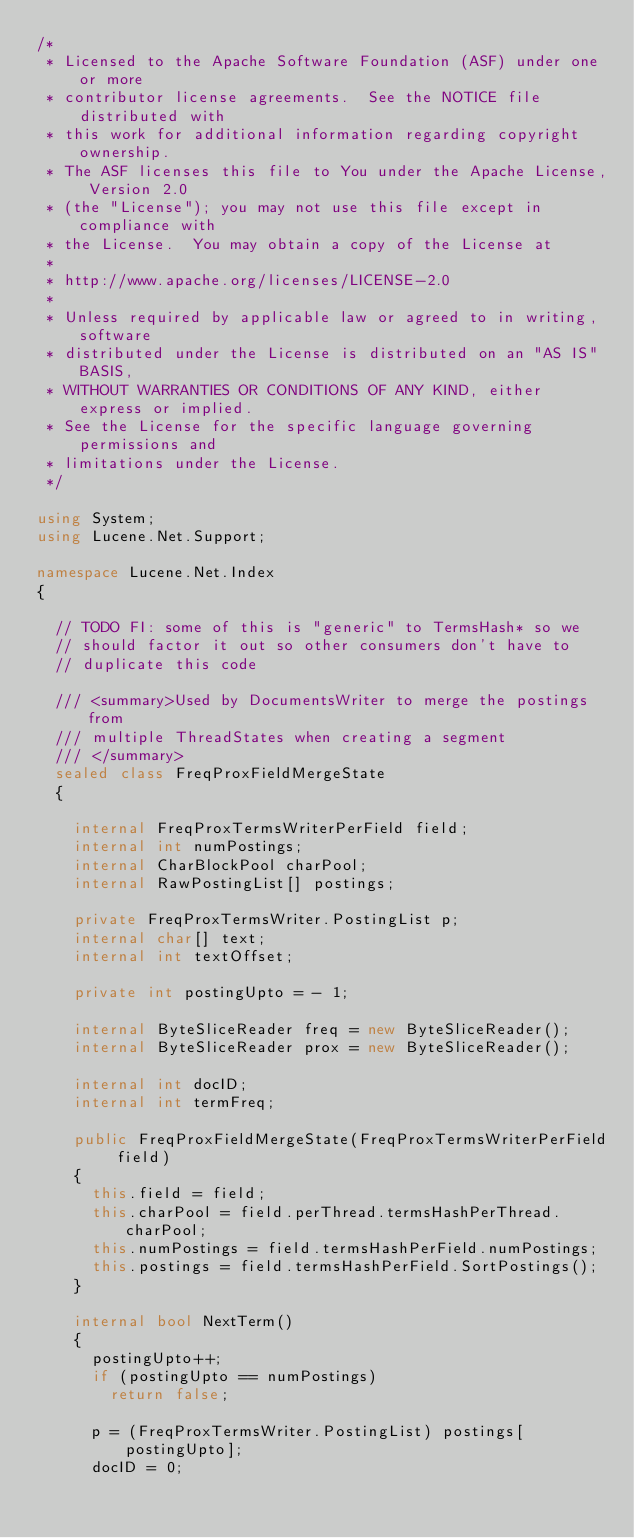Convert code to text. <code><loc_0><loc_0><loc_500><loc_500><_C#_>/* 
 * Licensed to the Apache Software Foundation (ASF) under one or more
 * contributor license agreements.  See the NOTICE file distributed with
 * this work for additional information regarding copyright ownership.
 * The ASF licenses this file to You under the Apache License, Version 2.0
 * (the "License"); you may not use this file except in compliance with
 * the License.  You may obtain a copy of the License at
 * 
 * http://www.apache.org/licenses/LICENSE-2.0
 * 
 * Unless required by applicable law or agreed to in writing, software
 * distributed under the License is distributed on an "AS IS" BASIS,
 * WITHOUT WARRANTIES OR CONDITIONS OF ANY KIND, either express or implied.
 * See the License for the specific language governing permissions and
 * limitations under the License.
 */

using System;
using Lucene.Net.Support;

namespace Lucene.Net.Index
{
	
	// TODO FI: some of this is "generic" to TermsHash* so we
	// should factor it out so other consumers don't have to
	// duplicate this code
	
	/// <summary>Used by DocumentsWriter to merge the postings from
	/// multiple ThreadStates when creating a segment 
	/// </summary>
	sealed class FreqProxFieldMergeState
	{
		
		internal FreqProxTermsWriterPerField field;
		internal int numPostings;
		internal CharBlockPool charPool;
		internal RawPostingList[] postings;
		
		private FreqProxTermsWriter.PostingList p;
		internal char[] text;
		internal int textOffset;
		
		private int postingUpto = - 1;
		
		internal ByteSliceReader freq = new ByteSliceReader();
		internal ByteSliceReader prox = new ByteSliceReader();
		
		internal int docID;
		internal int termFreq;
		
		public FreqProxFieldMergeState(FreqProxTermsWriterPerField field)
		{
			this.field = field;
			this.charPool = field.perThread.termsHashPerThread.charPool;
			this.numPostings = field.termsHashPerField.numPostings;
			this.postings = field.termsHashPerField.SortPostings();
		}
		
		internal bool NextTerm()
		{
			postingUpto++;
			if (postingUpto == numPostings)
				return false;
			
			p = (FreqProxTermsWriter.PostingList) postings[postingUpto];
			docID = 0;
			</code> 